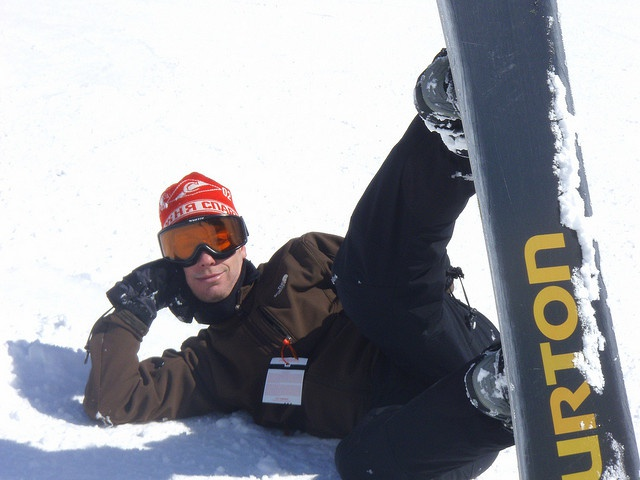Describe the objects in this image and their specific colors. I can see people in white, black, and gray tones and snowboard in white, gray, darkblue, and darkgray tones in this image. 